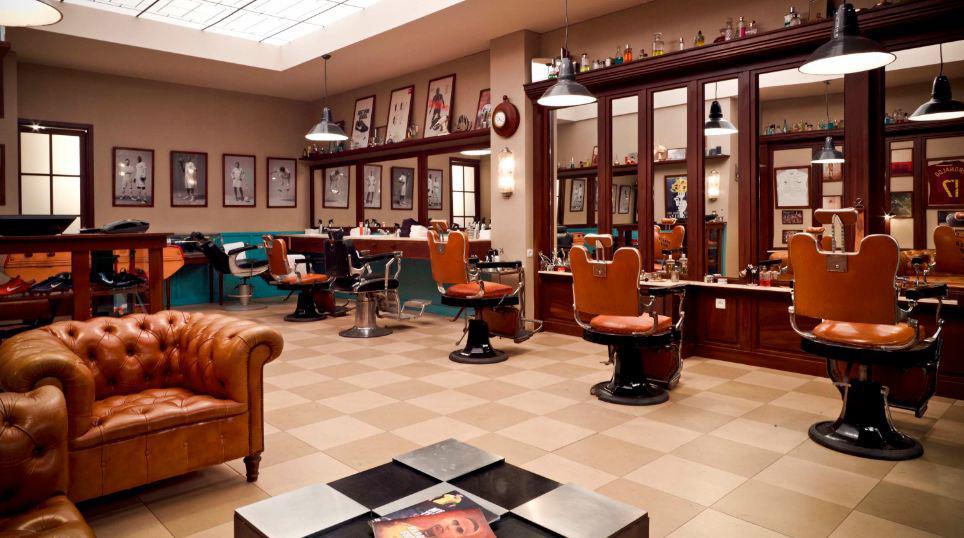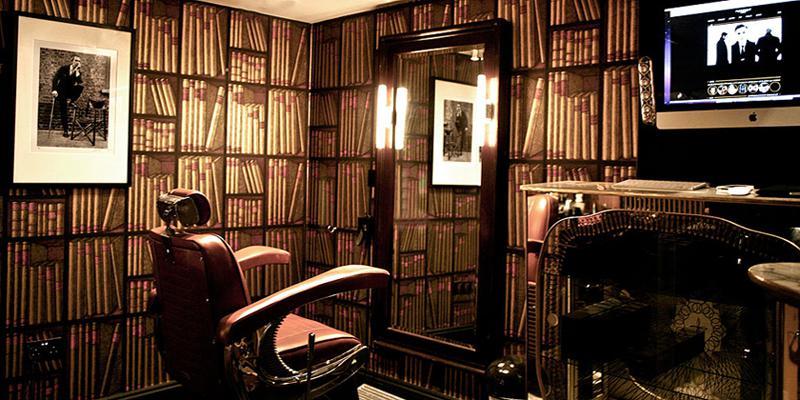The first image is the image on the left, the second image is the image on the right. For the images displayed, is the sentence "in at least one image there is a single empty barber chair facing a mirror next to a framed picture." factually correct? Answer yes or no. Yes. The first image is the image on the left, the second image is the image on the right. Assess this claim about the two images: "the left image contains at least three chairs, the right image only contains one.". Correct or not? Answer yes or no. Yes. 